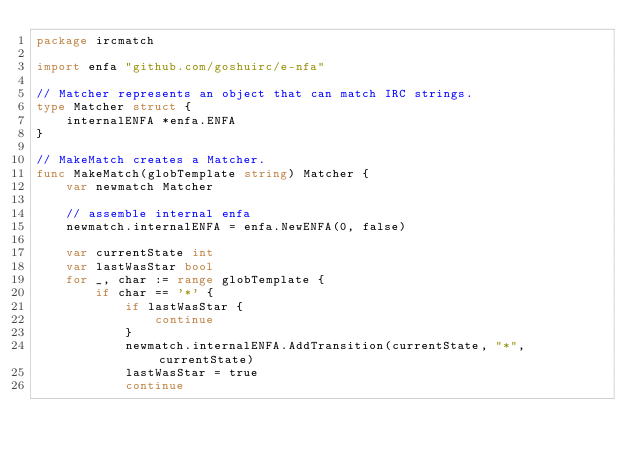<code> <loc_0><loc_0><loc_500><loc_500><_Go_>package ircmatch

import enfa "github.com/goshuirc/e-nfa"

// Matcher represents an object that can match IRC strings.
type Matcher struct {
	internalENFA *enfa.ENFA
}

// MakeMatch creates a Matcher.
func MakeMatch(globTemplate string) Matcher {
	var newmatch Matcher

	// assemble internal enfa
	newmatch.internalENFA = enfa.NewENFA(0, false)

	var currentState int
	var lastWasStar bool
	for _, char := range globTemplate {
		if char == '*' {
			if lastWasStar {
				continue
			}
			newmatch.internalENFA.AddTransition(currentState, "*", currentState)
			lastWasStar = true
			continue</code> 